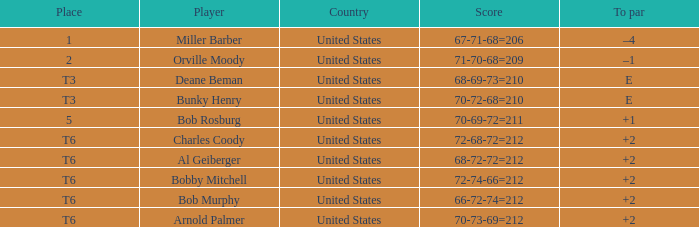What is the score of player bob rosburg? 70-69-72=211. 